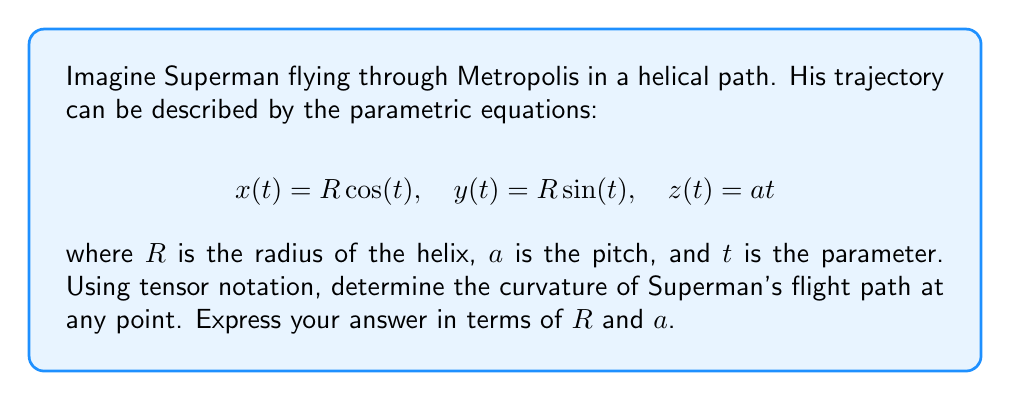What is the answer to this math problem? Let's approach this step-by-step:

1) First, we need to find the velocity vector. In tensor notation, this is given by:

   $$v^i = \frac{dx^i}{dt} = (-R\sin(t), R\cos(t), a)$$

2) The acceleration vector is the derivative of the velocity:

   $$a^i = \frac{dv^i}{dt} = (-R\cos(t), -R\sin(t), 0)$$

3) The magnitude of the velocity is:

   $$\|v\| = \sqrt{g_{ij}v^iv^j} = \sqrt{R^2\sin^2(t) + R^2\cos^2(t) + a^2} = \sqrt{R^2 + a^2}$$

4) The curvature $\kappa$ is given by:

   $$\kappa = \frac{\sqrt{|a^ia_i\|v\|^2 - (a_iv^i)^2|}}{\|v\|^3}$$

5) Let's calculate $a^ia_i$:

   $$a^ia_i = R^2\cos^2(t) + R^2\sin^2(t) = R^2$$

6) Now, $a_iv^i$:

   $$a_iv^i = -R^2\cos^2(t) - R^2\sin^2(t) = -R^2$$

7) Substituting into the curvature formula:

   $$\kappa = \frac{\sqrt{|R^2(R^2+a^2) - (-R^2)^2|}}{(R^2+a^2)^{3/2}}$$

8) Simplifying:

   $$\kappa = \frac{\sqrt{R^2(R^2+a^2) - R^4}}{(R^2+a^2)^{3/2}} = \frac{\sqrt{R^2a^2}}{(R^2+a^2)^{3/2}} = \frac{Ra}{(R^2+a^2)^{3/2}}$$
Answer: $$\kappa = \frac{Ra}{(R^2+a^2)^{3/2}}$$ 